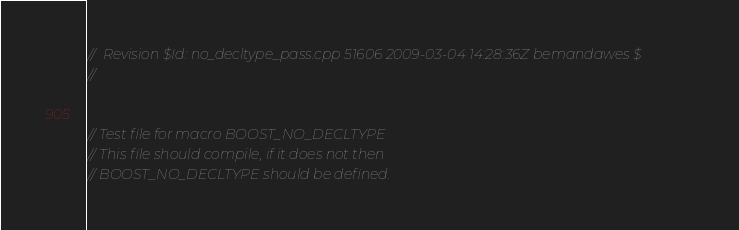Convert code to text. <code><loc_0><loc_0><loc_500><loc_500><_C++_>//  Revision $Id: no_decltype_pass.cpp 51606 2009-03-04 14:28:36Z bemandawes $
//


// Test file for macro BOOST_NO_DECLTYPE
// This file should compile, if it does not then
// BOOST_NO_DECLTYPE should be defined.</code> 